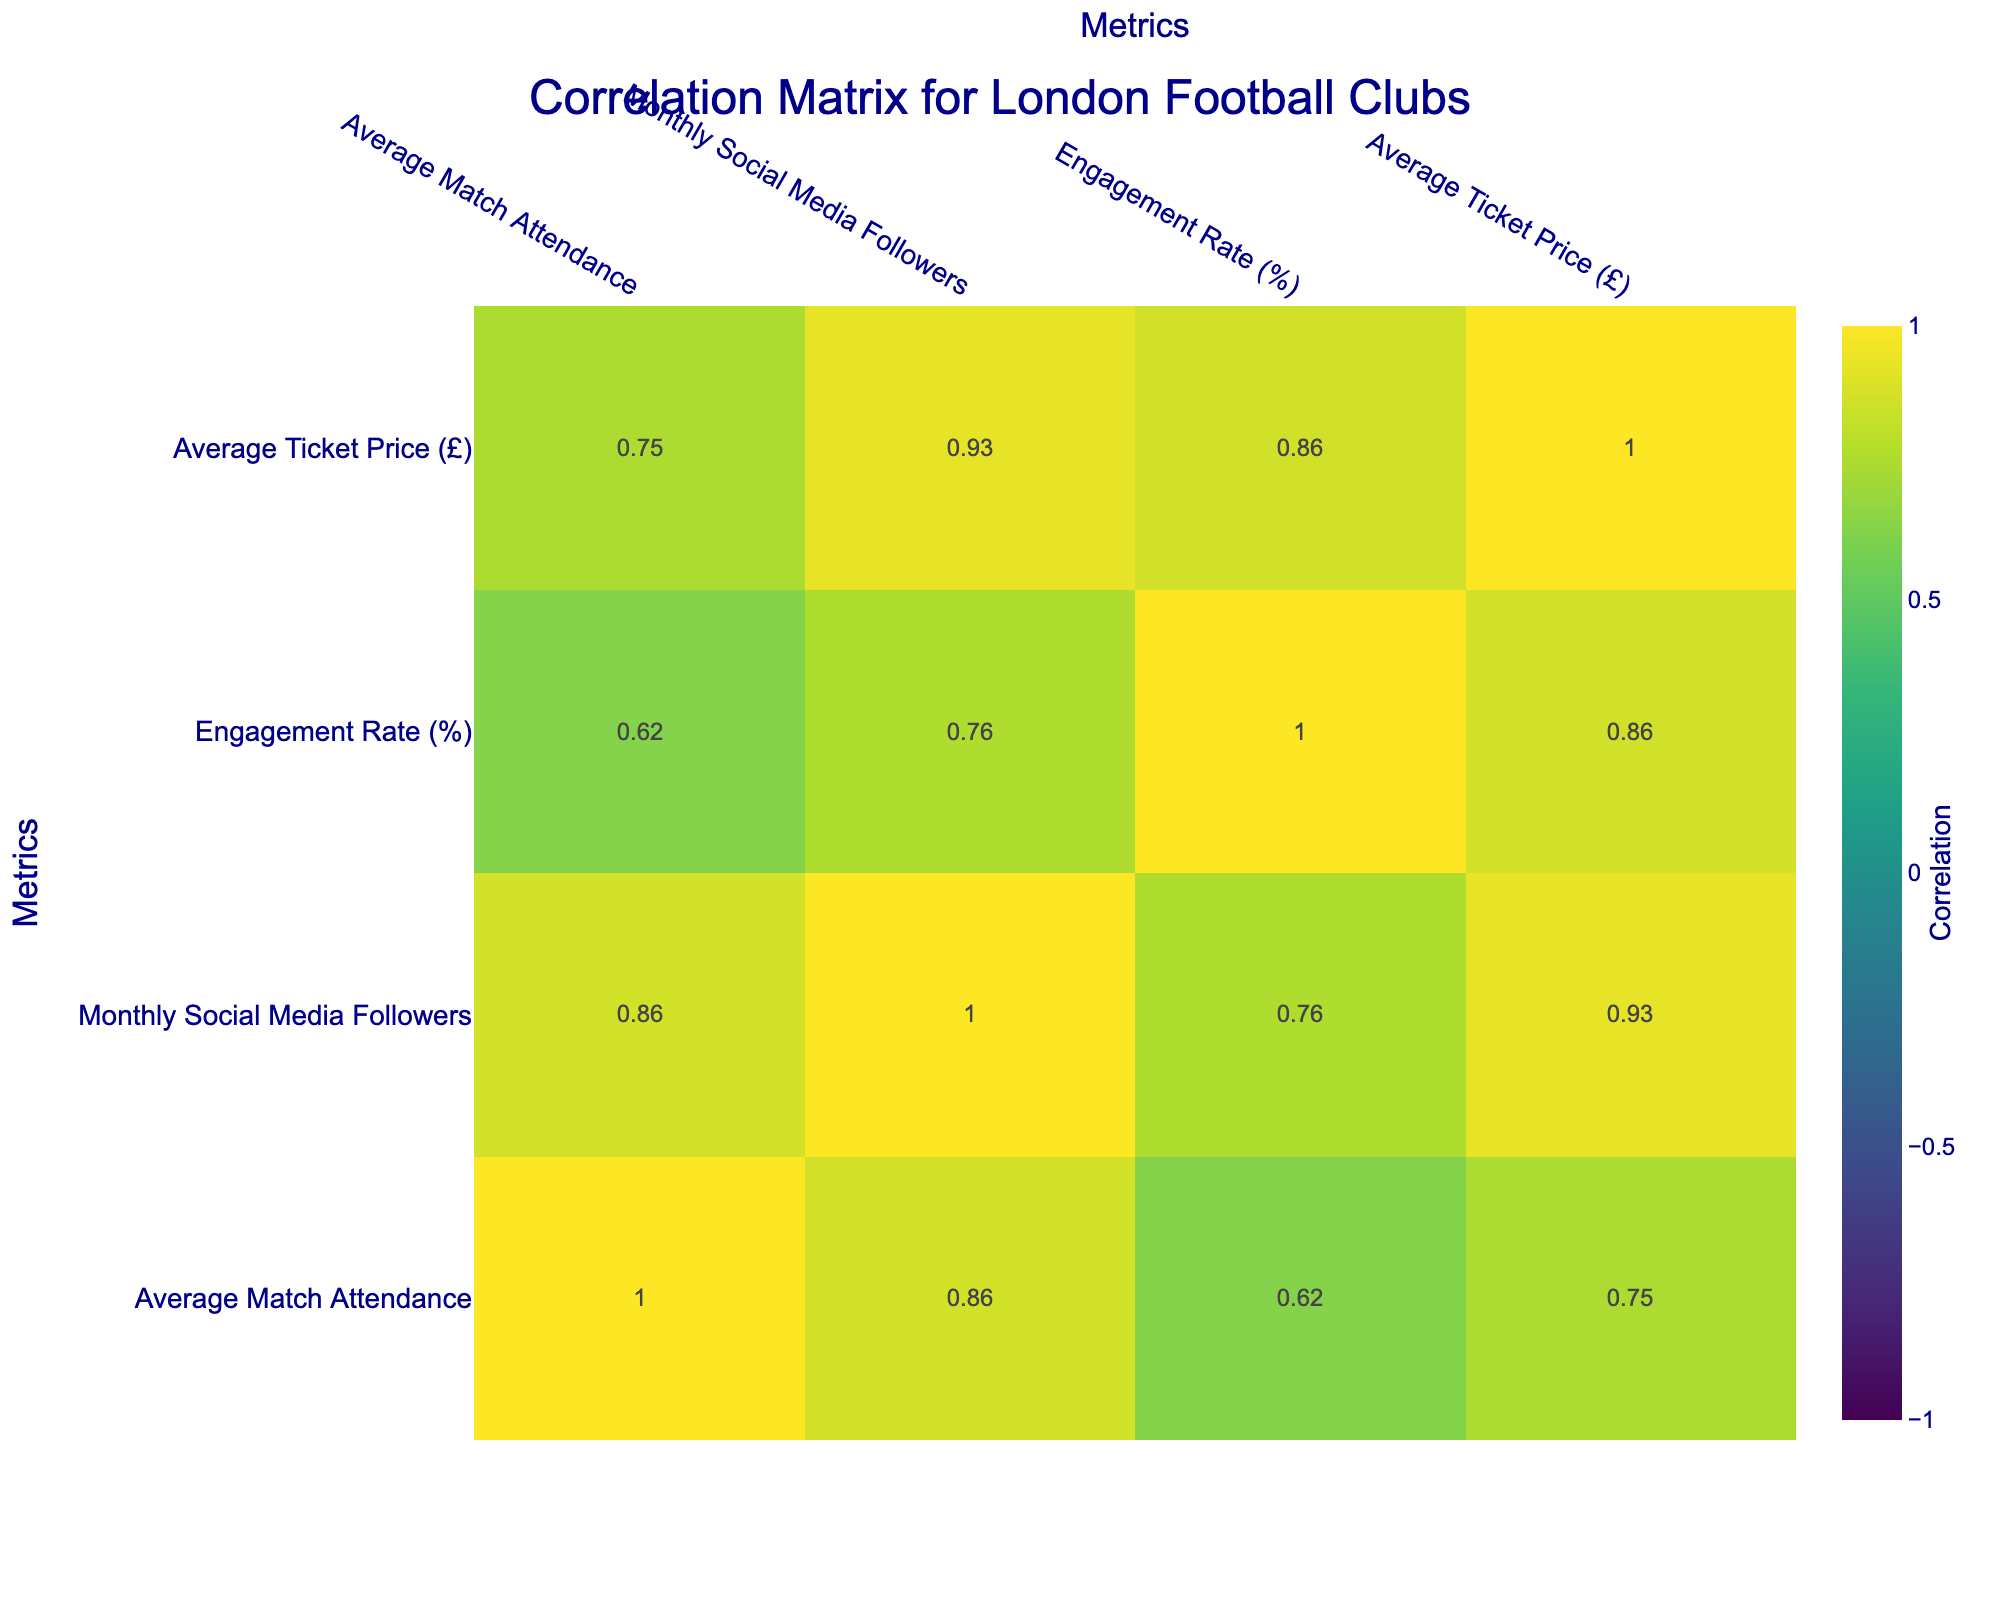What is the highest average match attendance among the clubs? By looking at the Average Match Attendance values in the table, Arsenal FC has the highest figure at 60,000.
Answer: 60,000 Which club has the highest engagement rate? The Engagement Rate column shows that Chelsea FC has the highest rate at 4.0%.
Answer: 4.0% What is the correlation between average match attendance and monthly social media followers? Referring to the correlation table, you would check the specific cell that corresponds to 'Average Match Attendance' and 'Monthly Social Media Followers.' This value will indicate the relationship; if it's close to 1, there's a strong positive correlation.
Answer: [Value based on the correlation table] Is the average ticket price positively correlated with engagement rate? By checking the correlation value between 'Average Ticket Price' and 'Engagement Rate', you can determine if it’s positive or negative. If the value is greater than 0, it's positive; otherwise, it’s not.
Answer: [Value based on the correlation table] How does the average ticket price of Tottenham compare to Crystal Palace? Tottenham has an average ticket price of £50, and Crystal Palace has £30. The difference between them is £50 - £30 = £20.
Answer: £20 If you consider only clubs with an engagement rate above 3.5, what is the average monthly social media following? First, filter the clubs to only those above 3.5% engagement (Arsenal FC, Chelsea FC, Tottenham Hotspur). Next, sum their monthly followers: 1,500,000 + 1,200,000 + 1,300,000 = 4,000,000. Since there are three clubs, divide by 3 to find the average: 4,000,000 / 3 = 1,333,333.
Answer: 1,333,333 Does a club's social media following tend to correlate with its average ticket price? Check the correlation coefficient between 'Monthly Social Media Followers' and 'Average Ticket Price'. If the value is close to 1 or -1, that indicates a tendency in correlation.
Answer: [Value based on the correlation table] Which club has the lowest average ticket price, and what is that price? From the Average Ticket Price column, Brentford FC has the lowest average ticket price at £25.
Answer: £25 